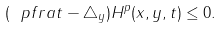Convert formula to latex. <formula><loc_0><loc_0><loc_500><loc_500>( \ p f r a { t } - \triangle _ { y } ) H ^ { p } ( x , y , t ) \leq 0 .</formula> 